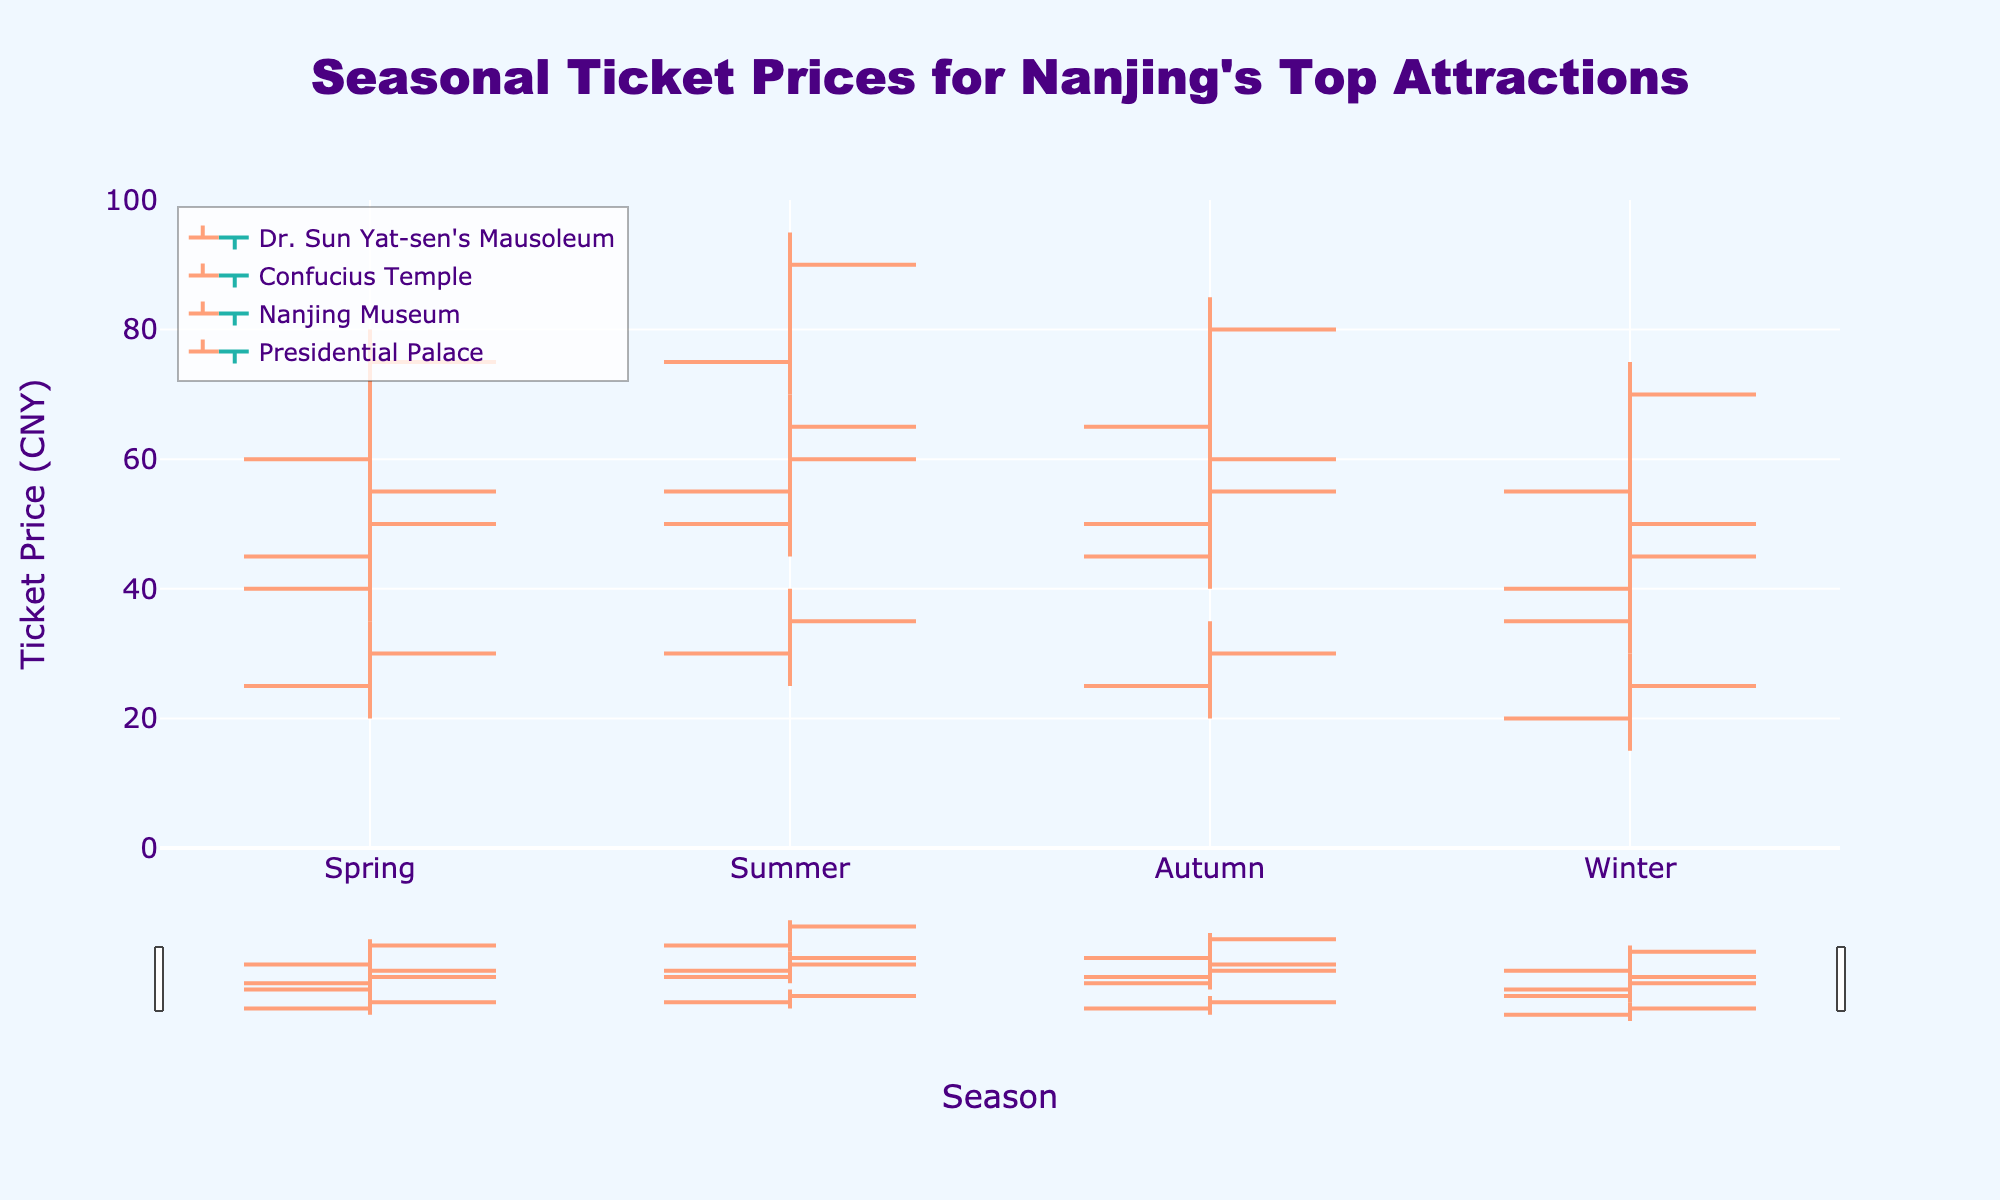What is the range of ticket prices for Dr. Sun Yat-sen's Mausoleum in Spring? The range of ticket prices can be calculated by subtracting the lowest price (Low) from the highest price (High). For Dr. Sun Yat-sen's Mausoleum in Spring: Range = High - Low = 80 - 55 = 25
Answer: 25 Which season shows the highest ticket price for Confucius Temple? To find the season with the highest ticket price for Confucius Temple, compare the High values for all seasons. The highest High value is in the Summer, which is 65.
Answer: Summer What is the average closing ticket price for Nanjing Museum across all seasons? To find the average, sum the closing prices for all seasons and divide by the number of seasons. (30 + 35 + 30 + 25) / 4 = 120 / 4 = 30
Answer: 30 In which season is the ticket price range the lowest for the Presidential Palace? To find the lowest range, calculate the range for each season and compare them. Spring: 60 - 40 = 20, Summer: 70 - 50 = 20, Autumn: 65 - 45 = 20, Winter: 55 - 35 = 20. All seasons have the same range.
Answer: All seasons Does the ticket price for any attraction in Summer decrease by the end? Check the Open and Close prices for each attraction in Summer to see if Close is lower than Open. None of the closing prices are lower than the opening prices in Summer.
Answer: No Which attraction has the highest closing price in Winter? Compare the Close prices for all attractions in Winter. The highest Close price is for Dr. Sun Yat-sen's Mausoleum, which is 70.
Answer: Dr. Sun Yat-sen's Mausoleum How does the ticket price of the Presidential Palace change from Autumn to Winter? Compare the Open, High, Low, and Close prices of the Presidential Palace between Autumn and Winter. Autumn (Open: 50, High: 65, Low: 45, Close: 60) and Winter (Open: 40, High: 55, Low: 35, Close: 50). There's a decrease in all price points from Autumn to Winter.
Answer: Decreases During which season is the ticket price volatility highest for Dr. Sun Yat-sen's Mausoleum? Volatility can be indicated by the range (High - Low). Calculating the range for each season: Spring: 25, Summer: 25, Autumn: 25, Winter: 25. The volatility is the same in all seasons.
Answer: All seasons What is the combined close price of all attractions in Autumn? Add the Close prices for all attractions in Autumn: (80 + 55 + 30 + 60) = 225
Answer: 225 